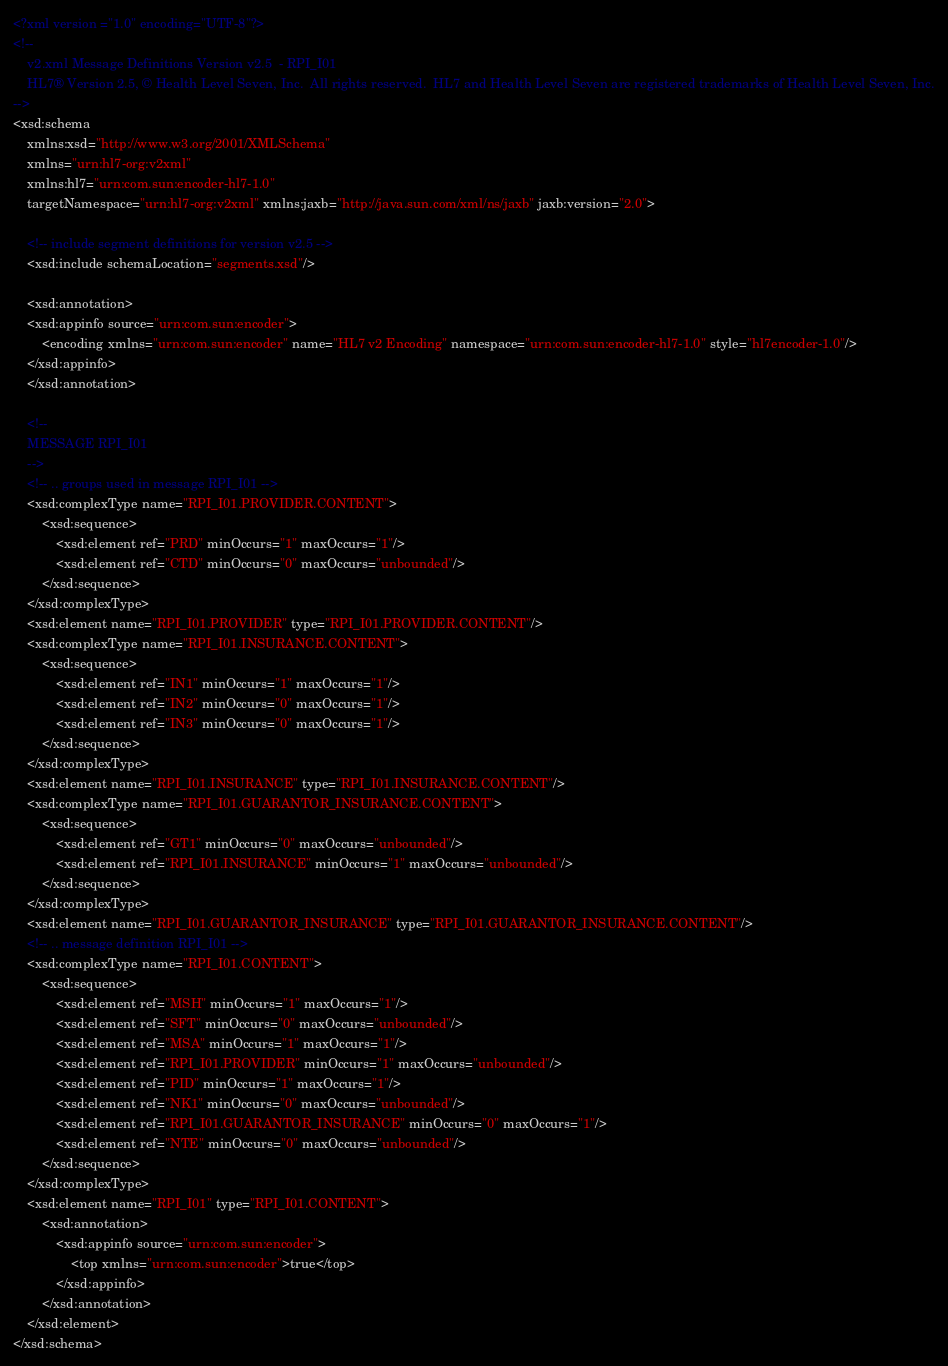Convert code to text. <code><loc_0><loc_0><loc_500><loc_500><_XML_><?xml version ="1.0" encoding="UTF-8"?>
<!--
    v2.xml Message Definitions Version v2.5  - RPI_I01
    HL7® Version 2.5, © Health Level Seven, Inc.  All rights reserved.  HL7 and Health Level Seven are registered trademarks of Health Level Seven, Inc.
-->
<xsd:schema
    xmlns:xsd="http://www.w3.org/2001/XMLSchema"
    xmlns="urn:hl7-org:v2xml"
    xmlns:hl7="urn:com.sun:encoder-hl7-1.0"
    targetNamespace="urn:hl7-org:v2xml" xmlns:jaxb="http://java.sun.com/xml/ns/jaxb" jaxb:version="2.0">

    <!-- include segment definitions for version v2.5 -->
    <xsd:include schemaLocation="segments.xsd"/>

    <xsd:annotation>
	<xsd:appinfo source="urn:com.sun:encoder">
	    <encoding xmlns="urn:com.sun:encoder" name="HL7 v2 Encoding" namespace="urn:com.sun:encoder-hl7-1.0" style="hl7encoder-1.0"/>
	</xsd:appinfo>
    </xsd:annotation>

    <!--
	MESSAGE RPI_I01
    -->
    <!-- .. groups used in message RPI_I01 -->
    <xsd:complexType name="RPI_I01.PROVIDER.CONTENT">
        <xsd:sequence>
            <xsd:element ref="PRD" minOccurs="1" maxOccurs="1"/>
            <xsd:element ref="CTD" minOccurs="0" maxOccurs="unbounded"/>
        </xsd:sequence>
    </xsd:complexType>
    <xsd:element name="RPI_I01.PROVIDER" type="RPI_I01.PROVIDER.CONTENT"/>
    <xsd:complexType name="RPI_I01.INSURANCE.CONTENT">
        <xsd:sequence>
            <xsd:element ref="IN1" minOccurs="1" maxOccurs="1"/>
            <xsd:element ref="IN2" minOccurs="0" maxOccurs="1"/>
            <xsd:element ref="IN3" minOccurs="0" maxOccurs="1"/>
        </xsd:sequence>
    </xsd:complexType>
    <xsd:element name="RPI_I01.INSURANCE" type="RPI_I01.INSURANCE.CONTENT"/>
    <xsd:complexType name="RPI_I01.GUARANTOR_INSURANCE.CONTENT">
        <xsd:sequence>
            <xsd:element ref="GT1" minOccurs="0" maxOccurs="unbounded"/>
            <xsd:element ref="RPI_I01.INSURANCE" minOccurs="1" maxOccurs="unbounded"/>
        </xsd:sequence>
    </xsd:complexType>
    <xsd:element name="RPI_I01.GUARANTOR_INSURANCE" type="RPI_I01.GUARANTOR_INSURANCE.CONTENT"/>
    <!-- .. message definition RPI_I01 -->
    <xsd:complexType name="RPI_I01.CONTENT">
        <xsd:sequence>
            <xsd:element ref="MSH" minOccurs="1" maxOccurs="1"/>
            <xsd:element ref="SFT" minOccurs="0" maxOccurs="unbounded"/>
            <xsd:element ref="MSA" minOccurs="1" maxOccurs="1"/>
            <xsd:element ref="RPI_I01.PROVIDER" minOccurs="1" maxOccurs="unbounded"/>
            <xsd:element ref="PID" minOccurs="1" maxOccurs="1"/>
            <xsd:element ref="NK1" minOccurs="0" maxOccurs="unbounded"/>
            <xsd:element ref="RPI_I01.GUARANTOR_INSURANCE" minOccurs="0" maxOccurs="1"/>
            <xsd:element ref="NTE" minOccurs="0" maxOccurs="unbounded"/>
        </xsd:sequence>
    </xsd:complexType>
    <xsd:element name="RPI_I01" type="RPI_I01.CONTENT">
        <xsd:annotation>
            <xsd:appinfo source="urn:com.sun:encoder">
                <top xmlns="urn:com.sun:encoder">true</top>
            </xsd:appinfo>
        </xsd:annotation>
    </xsd:element>
</xsd:schema>
</code> 